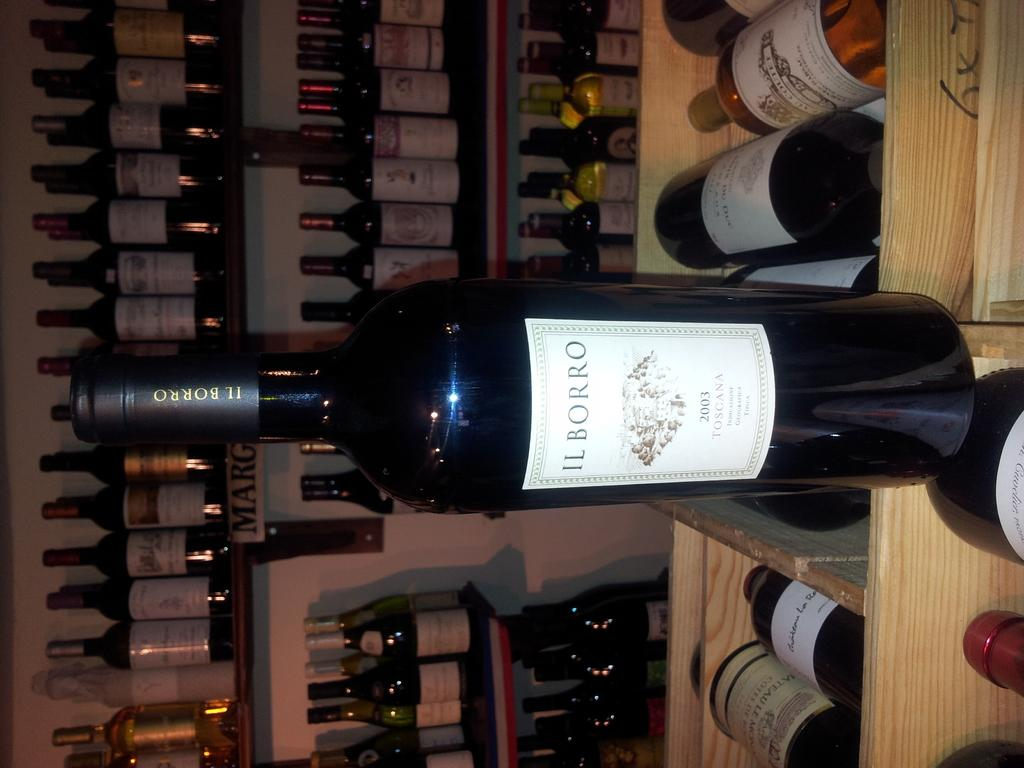<image>
Relay a brief, clear account of the picture shown. a bottle of il borro 2003 toscana wine from france 